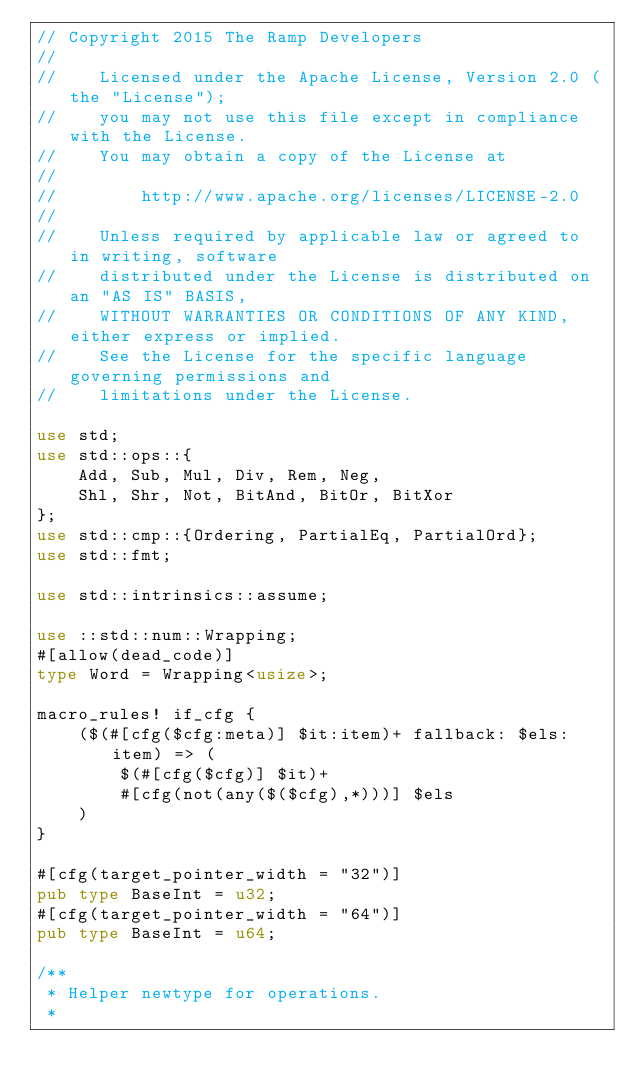Convert code to text. <code><loc_0><loc_0><loc_500><loc_500><_Rust_>// Copyright 2015 The Ramp Developers
//
//    Licensed under the Apache License, Version 2.0 (the "License");
//    you may not use this file except in compliance with the License.
//    You may obtain a copy of the License at
//
//        http://www.apache.org/licenses/LICENSE-2.0
//
//    Unless required by applicable law or agreed to in writing, software
//    distributed under the License is distributed on an "AS IS" BASIS,
//    WITHOUT WARRANTIES OR CONDITIONS OF ANY KIND, either express or implied.
//    See the License for the specific language governing permissions and
//    limitations under the License.

use std;
use std::ops::{
    Add, Sub, Mul, Div, Rem, Neg,
    Shl, Shr, Not, BitAnd, BitOr, BitXor
};
use std::cmp::{Ordering, PartialEq, PartialOrd};
use std::fmt;

use std::intrinsics::assume;

use ::std::num::Wrapping;
#[allow(dead_code)]
type Word = Wrapping<usize>;

macro_rules! if_cfg {
    ($(#[cfg($cfg:meta)] $it:item)+ fallback: $els:item) => (
        $(#[cfg($cfg)] $it)+
        #[cfg(not(any($($cfg),*)))] $els
    )
}

#[cfg(target_pointer_width = "32")]
pub type BaseInt = u32;
#[cfg(target_pointer_width = "64")]
pub type BaseInt = u64;

/**
 * Helper newtype for operations.
 *</code> 